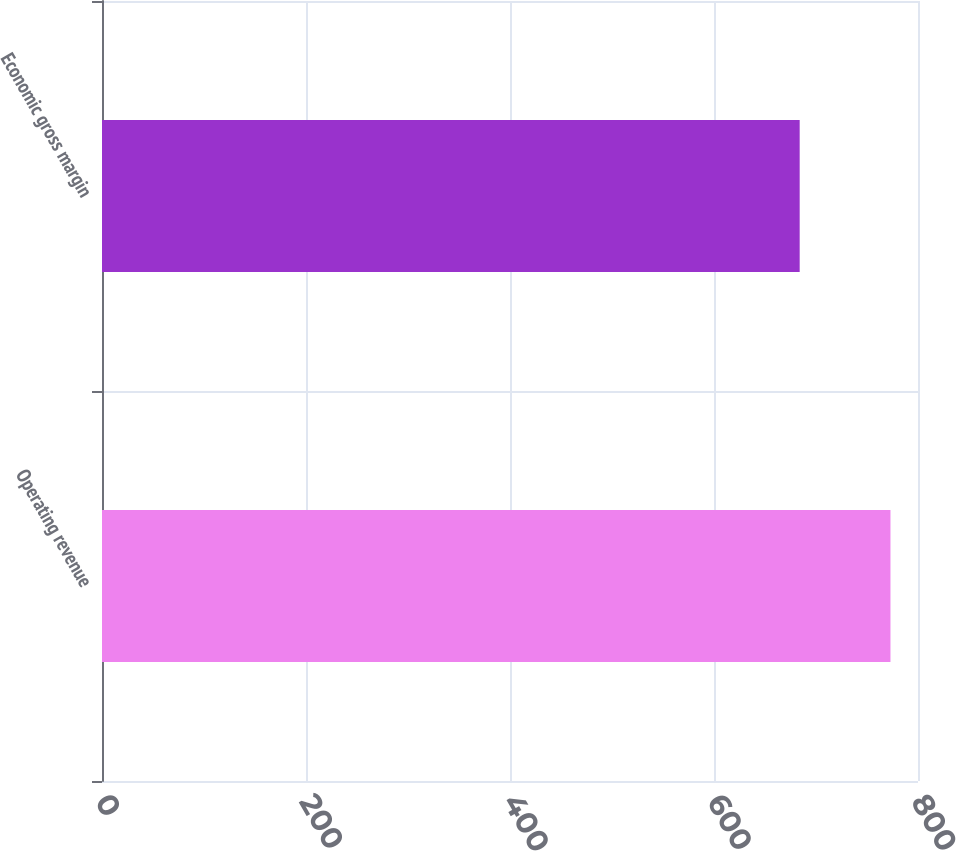Convert chart to OTSL. <chart><loc_0><loc_0><loc_500><loc_500><bar_chart><fcel>Operating revenue<fcel>Economic gross margin<nl><fcel>773<fcel>684<nl></chart> 